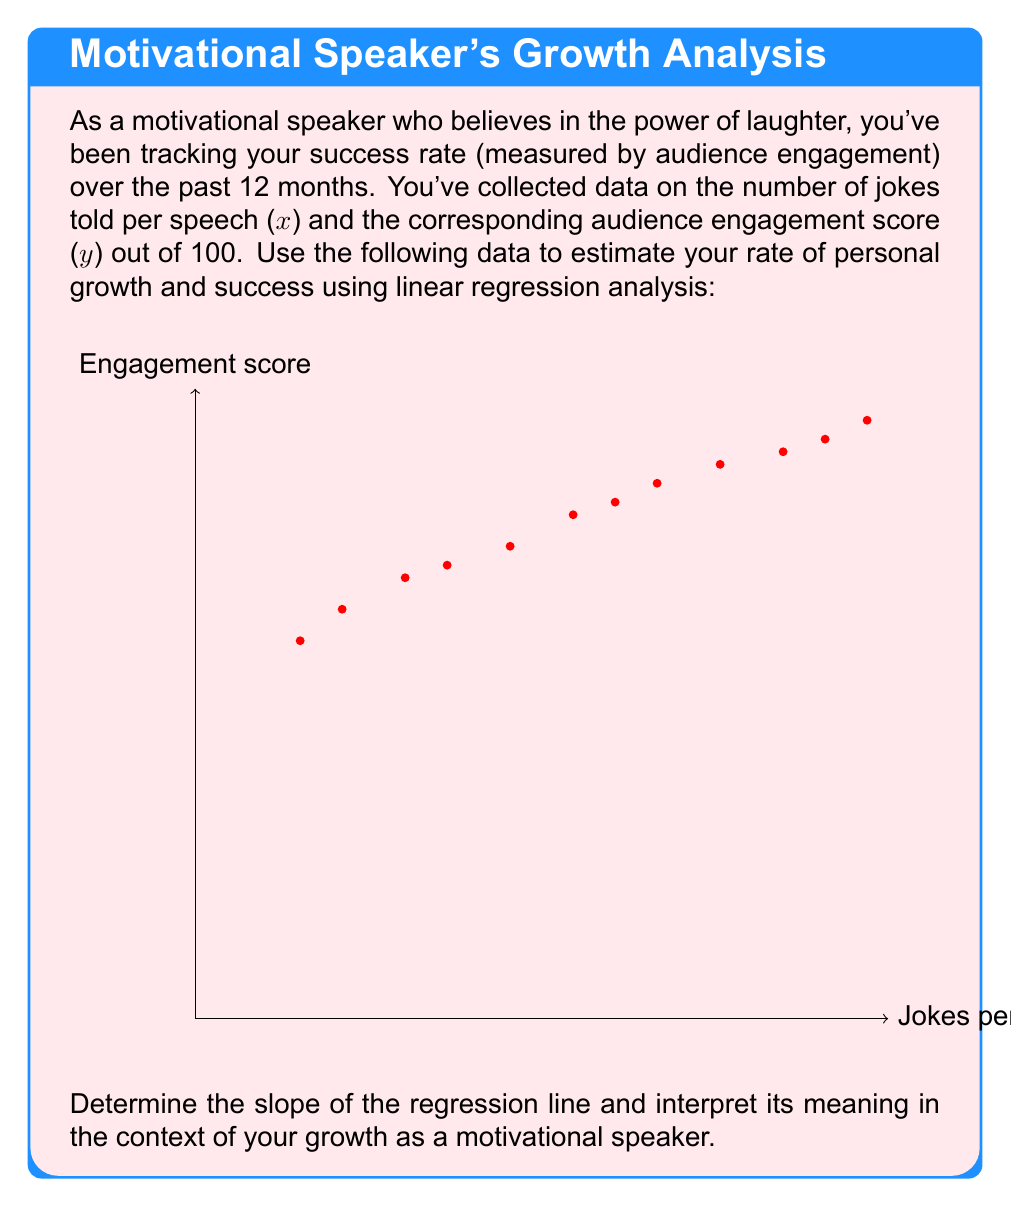Can you solve this math problem? To solve this problem, we'll use linear regression analysis. The steps are as follows:

1) First, we need to calculate the means of x and y:
   $\bar{x} = \frac{\sum x_i}{n} = \frac{224}{12} = 18.67$
   $\bar{y} = \frac{\sum y_i}{n} = \frac{954}{12} = 79.5$

2) Next, we calculate the slope (b) of the regression line using the formula:
   $b = \frac{\sum (x_i - \bar{x})(y_i - \bar{y})}{\sum (x_i - \bar{x})^2}$

3) To do this, we need to calculate:
   $\sum (x_i - \bar{x})(y_i - \bar{y}) = 1726.67$
   $\sum (x_i - \bar{x})^2 = 1548.67$

4) Now we can calculate the slope:
   $b = \frac{1726.67}{1548.67} = 1.115$

5) The slope represents the rate of change in the engagement score for each additional joke told. In this case, for each additional joke told, the audience engagement score increases by approximately 1.115 points.

6) To interpret this in the context of personal growth and success:
   The positive slope indicates that as you incorporate more jokes into your speeches, your audience engagement (and thus, your success as a motivational speaker) is increasing. This suggests a positive rate of personal growth and improvement in your speaking skills over time.
Answer: Slope = 1.115; Each additional joke increases engagement by 1.115 points, indicating positive personal growth. 